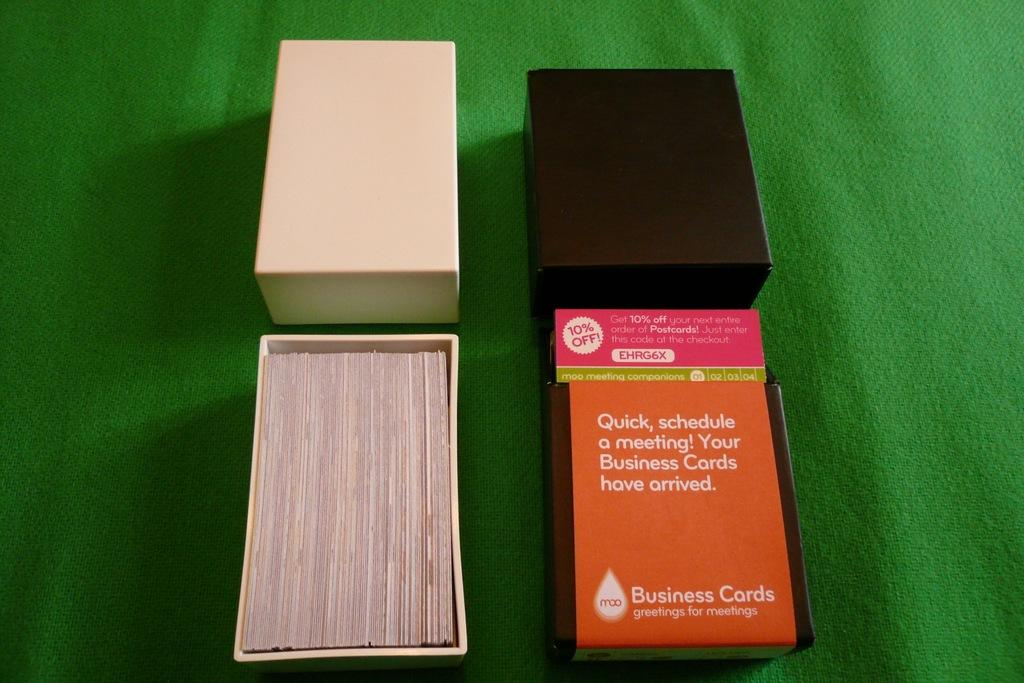<image>
Give a short and clear explanation of the subsequent image. four boxes of business cards on a green table, with coupon code EHRG6X on one of the boxes 